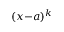Convert formula to latex. <formula><loc_0><loc_0><loc_500><loc_500>( x { - } a ) ^ { k }</formula> 